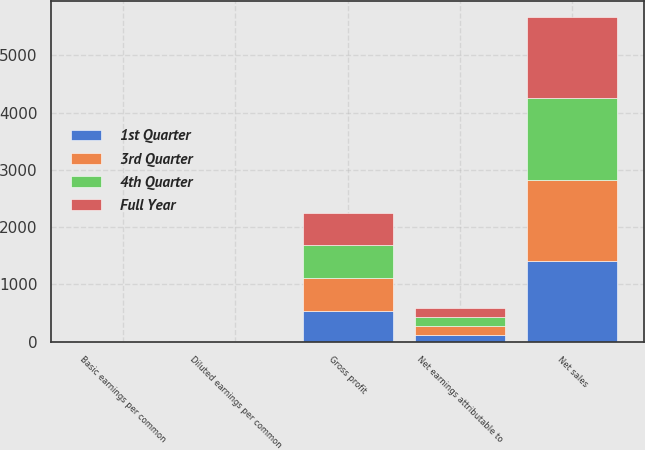<chart> <loc_0><loc_0><loc_500><loc_500><stacked_bar_chart><ecel><fcel>Net sales<fcel>Gross profit<fcel>Net earnings attributable to<fcel>Basic earnings per common<fcel>Diluted earnings per common<nl><fcel>4th Quarter<fcel>1423.3<fcel>576.1<fcel>161.6<fcel>1.66<fcel>1.63<nl><fcel>3rd Quarter<fcel>1423.4<fcel>579.5<fcel>153.3<fcel>1.59<fcel>1.56<nl><fcel>Full Year<fcel>1419.4<fcel>556.1<fcel>148<fcel>1.56<fcel>1.53<nl><fcel>1st Quarter<fcel>1405.3<fcel>538<fcel>120.2<fcel>1.28<fcel>1.26<nl></chart> 